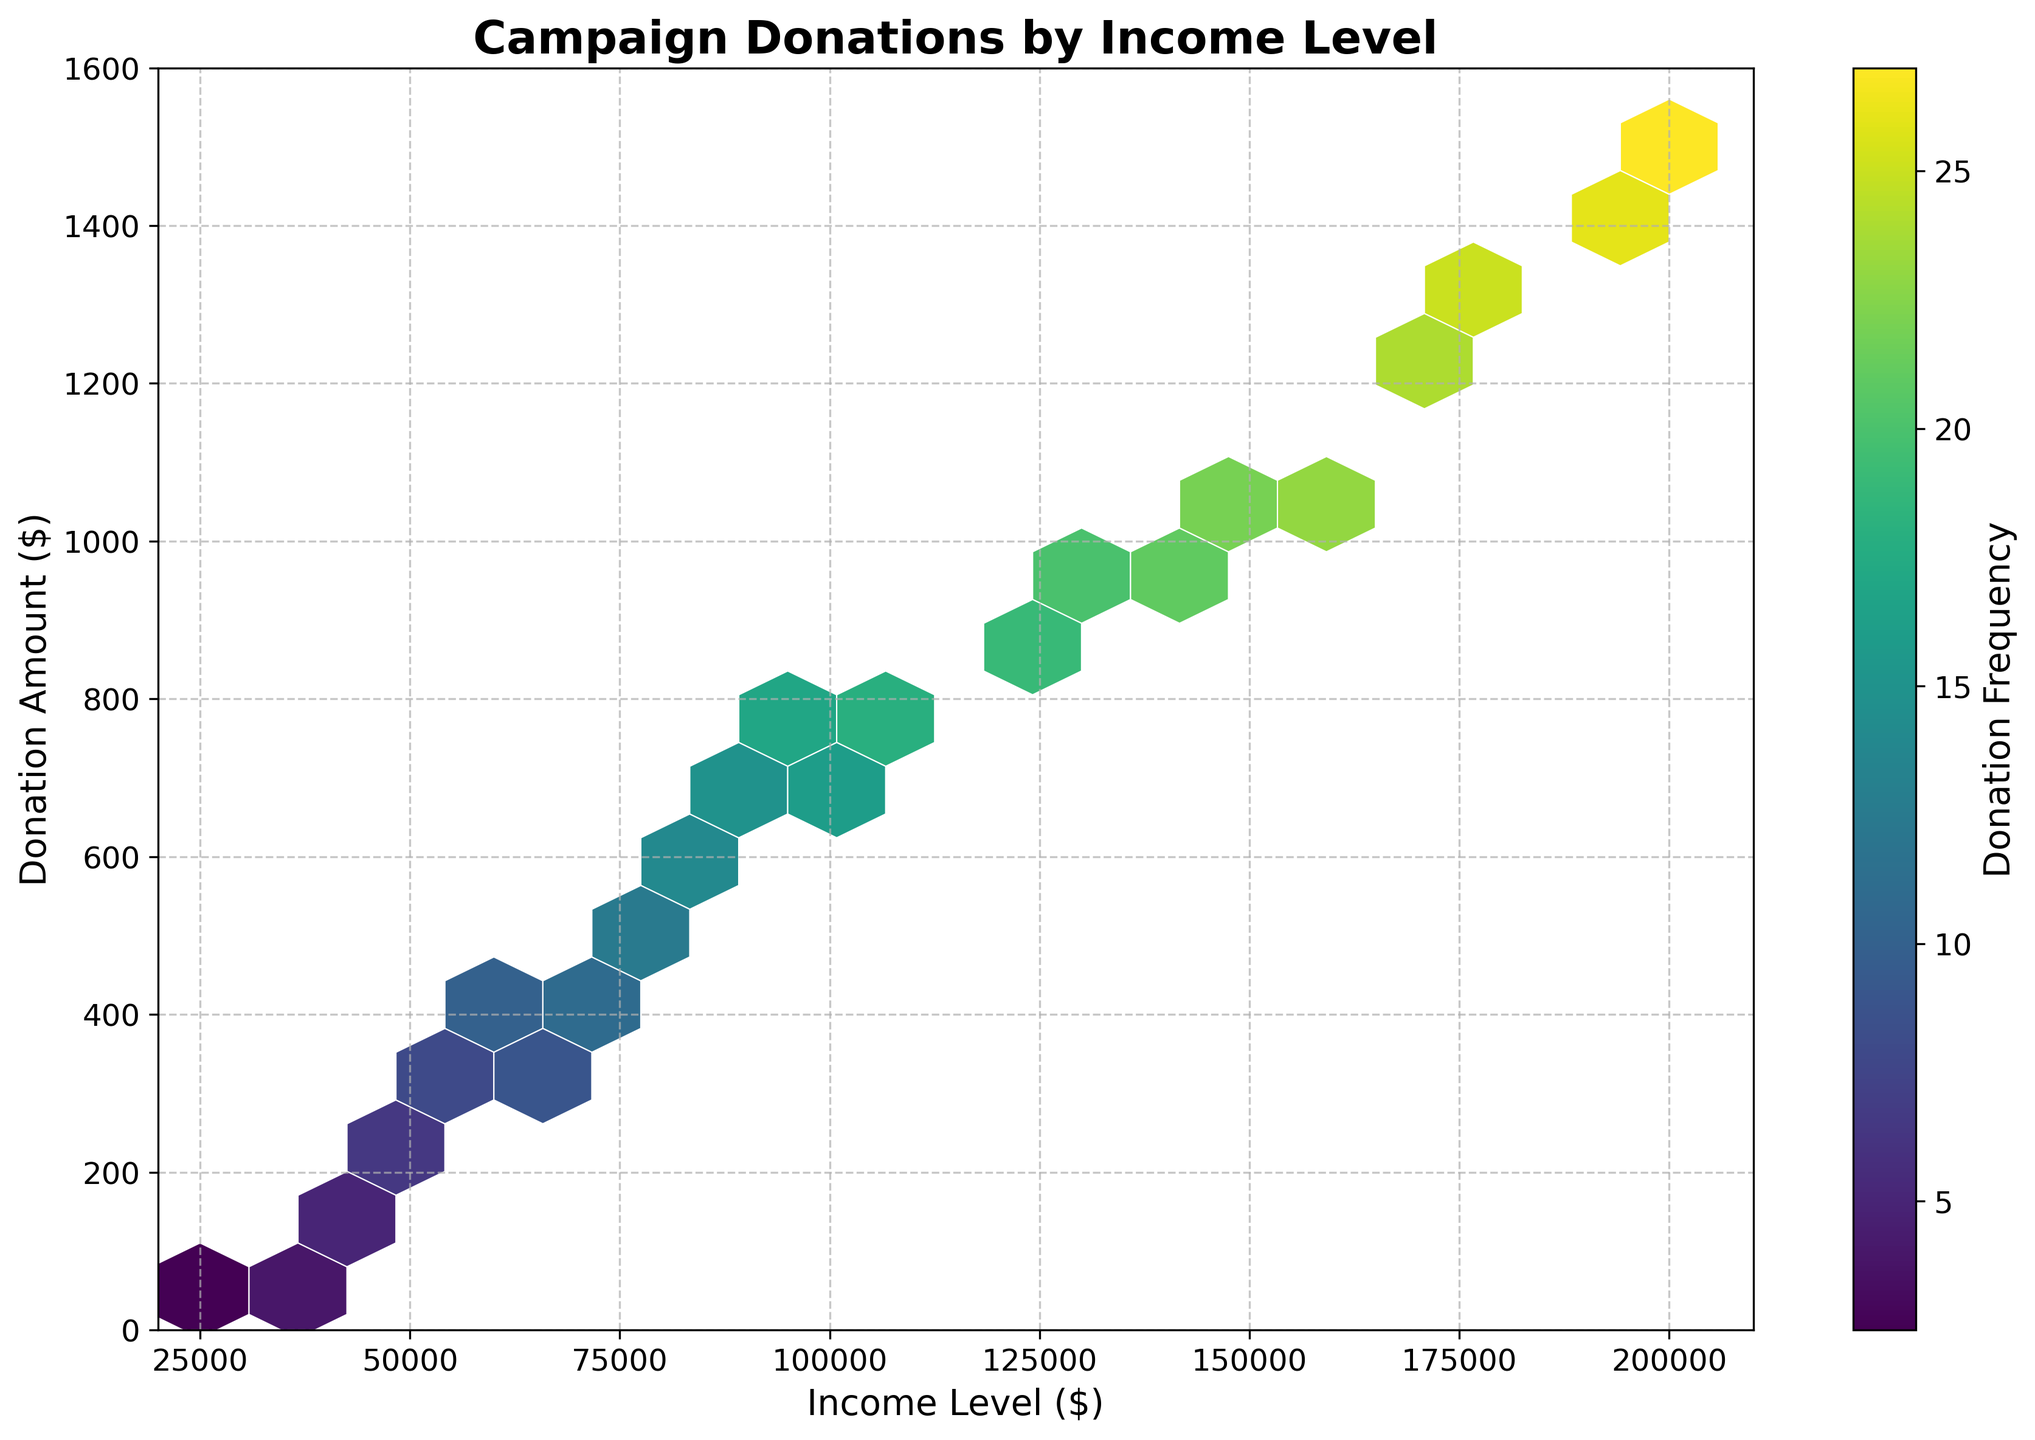what is the title of the plot? The title of the plot is positioned at the top of the plot and clearly states the subject being analyzed.
Answer: Campaign Donations by Income Level Which income level has the highest donation amount? The hexbin plot shows different hexagons representing varying donation amounts across income levels. The topmost hexagons on the y-axis represent the highest donation amounts.
Answer: $200,000 What is the color of the hexagon with the highest donation frequency? The plot uses a color gradient to indicate donation frequency. Hexagons with the highest frequency are represented by colors at the top of the gradient scale ('viridis'). By observing such a hexagon's color, we can determine its frequency.
Answer: Dark Purple What is the range of donation amounts represented on the y-axis? The y-axis labels indicate the range of donation amounts.
Answer: 0 to 1600 Is there a noticeable trend between income level and donation amount? By examining the distribution of hexagons across the plot, we can see if there is a consistent pattern as the income level changes.
Answer: Yes, higher income levels correspond to higher donation amounts Which income level range shows the most frequent donations? The color intensity on the plot indicates donation frequency. We need to observe the range of income levels where the most intense colors are concentrated.
Answer: $100,000 - $150,000 Are donations more frequent at higher or lower income levels? Comparing the hexagon colors across different income ranges reveals which income levels have higher donation frequencies.
Answer: Higher income levels What is the average donation amount at an income level of $75,000? The plot illustrates donation amounts through y-axis labels and hexagons' vertical positions. By identifying the donation amount hexagons at $75,000 income, we can estimate the average. Since the plot shows even distributions, we average the approximate amounts.
Answer: $500 How does the donation frequency change as income level increases from $50,000 to $150,000? Observe the color changes (donation frequency) across these income levels on the plot to note any patterns or shifts in frequency.
Answer: It increases What's the grid size of the hexbin plot? The plot's grid size determines how many hexagons are generated for the given data ranges. Hexbin’s density and coverage provide a visual estimate of the grid size parameter used.
Answer: 15 